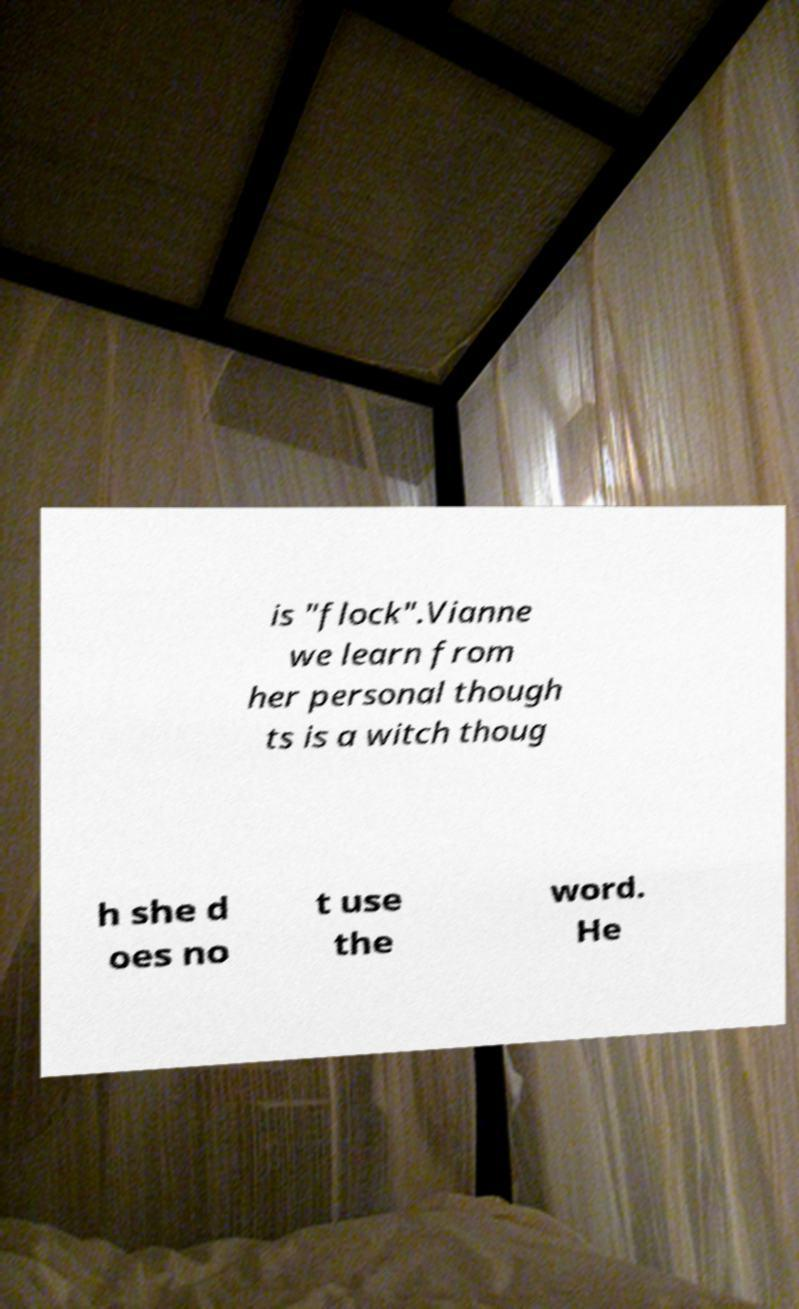There's text embedded in this image that I need extracted. Can you transcribe it verbatim? is "flock".Vianne we learn from her personal though ts is a witch thoug h she d oes no t use the word. He 